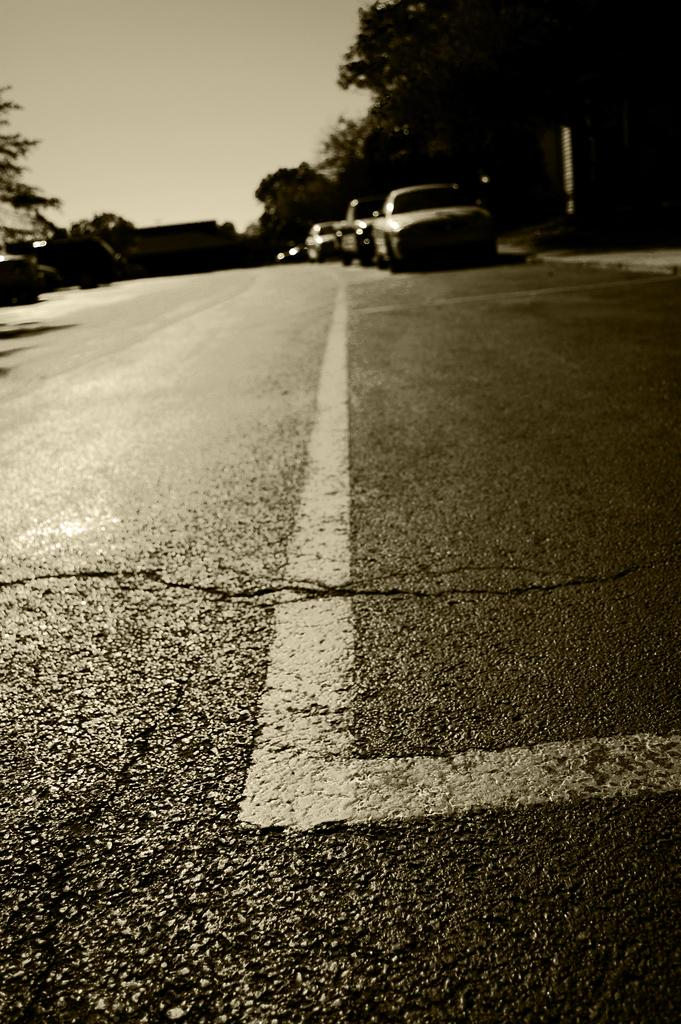What is the main feature of the image? There is a road in the image. What else can be seen on the road? There are vehicles in the image. What type of natural elements are present in the image? There are trees in the image. What else can be seen in the image besides the road, vehicles, and trees? There are some objects in the image. What is visible in the background of the image? The sky is visible in the background of the image. Can you see a volleyball game happening in the image? No, there is no volleyball game present in the image. Are there any marbles visible in the image? No, there are no marbles visible in the image. 